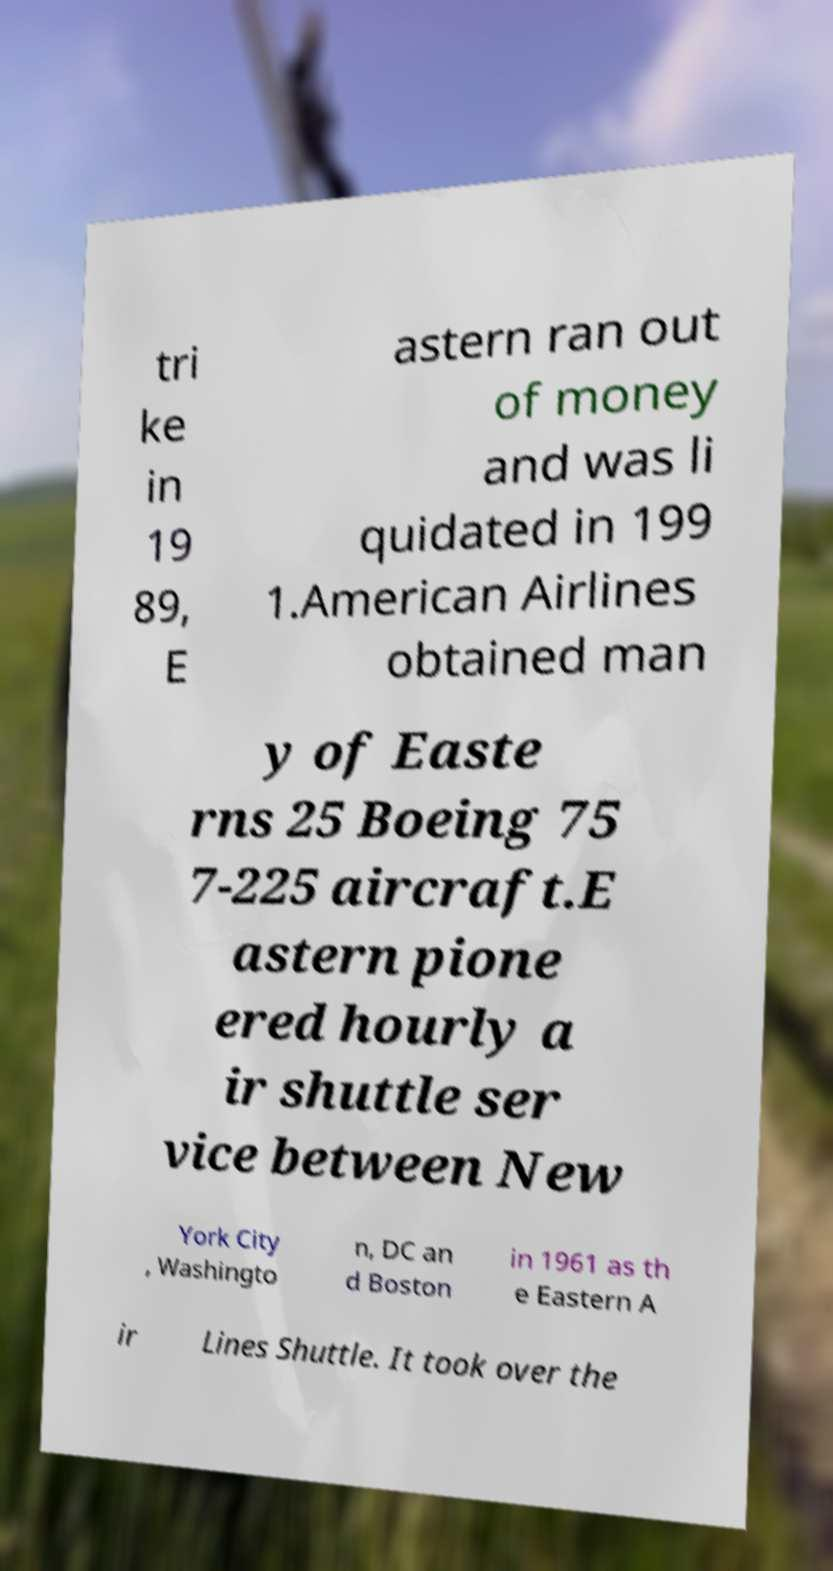I need the written content from this picture converted into text. Can you do that? tri ke in 19 89, E astern ran out of money and was li quidated in 199 1.American Airlines obtained man y of Easte rns 25 Boeing 75 7-225 aircraft.E astern pione ered hourly a ir shuttle ser vice between New York City , Washingto n, DC an d Boston in 1961 as th e Eastern A ir Lines Shuttle. It took over the 